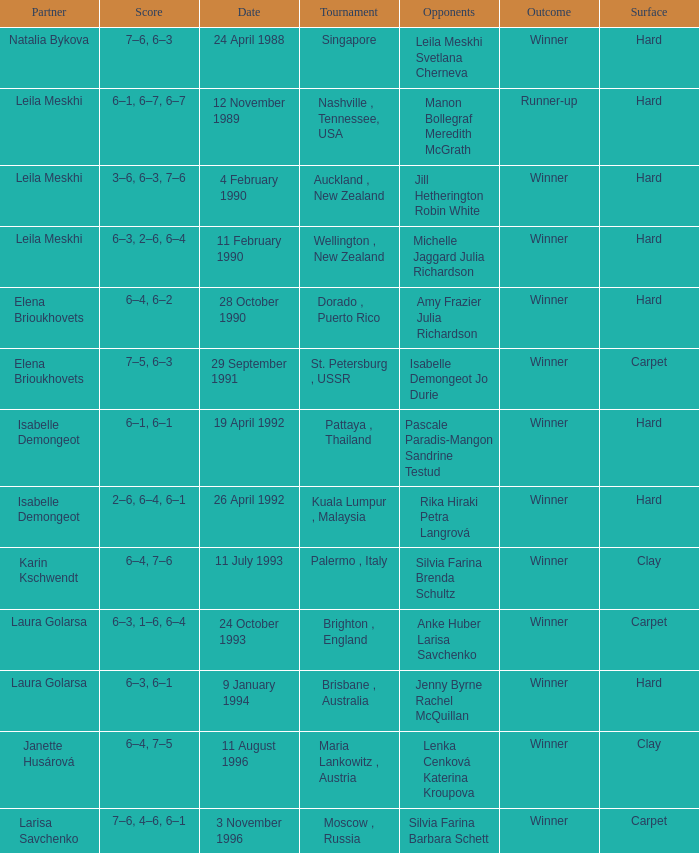Who was the Partner in a game with the Score of 6–4, 6–2 on a hard surface? Elena Brioukhovets. 